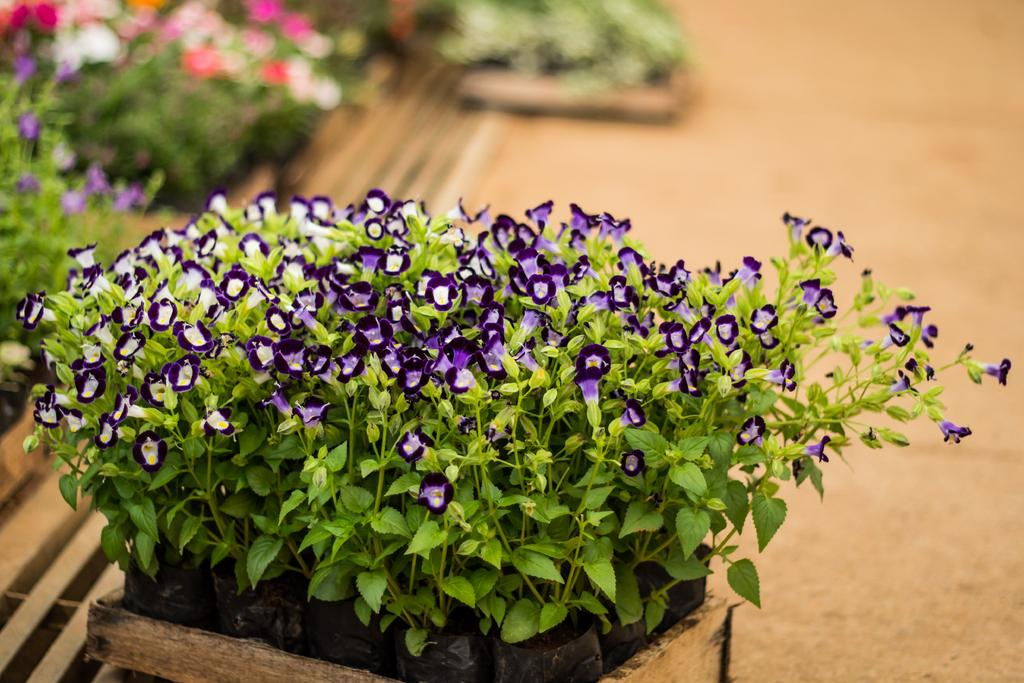What type of plants are in the image? There are small flower plants in the image. How is the background of the image depicted? The background of the flower plants is blurred. What type of house can be seen in the background of the image? There is no house present in the image; the background is blurred and only shows the small flower plants. 